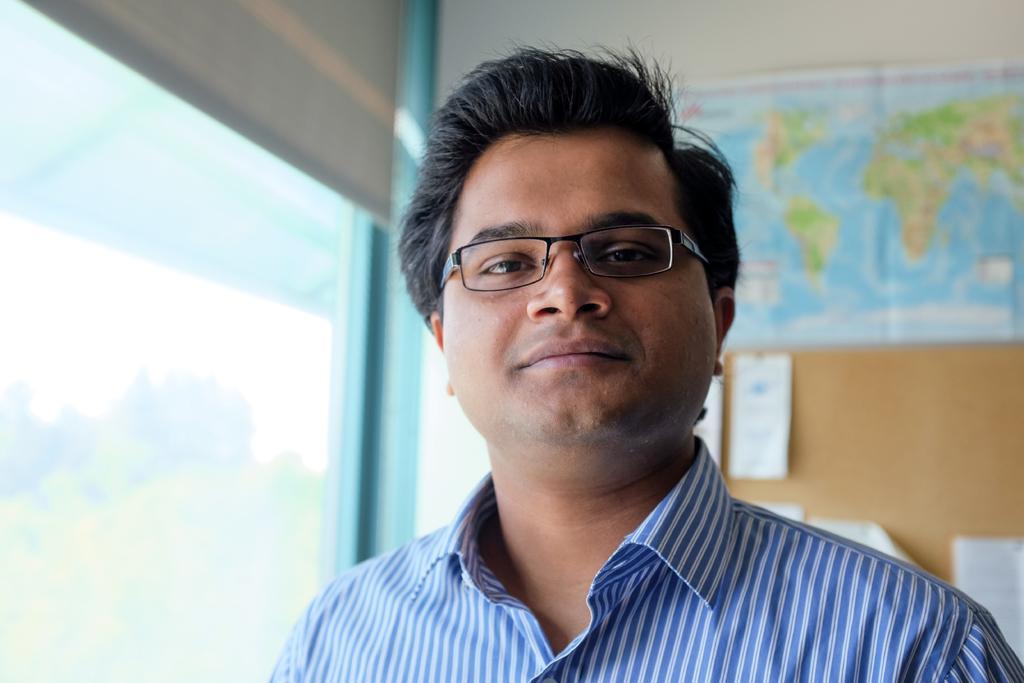Describe this image in one or two sentences. In this image I can see a person wearing blue colored dress and black colored spectacles. In the background I can see the white colored wall, a map and a brown colored board attached to the wall. On the board I can see few papers attached. I can see the glass window and through it I can see few trees and the sky. 